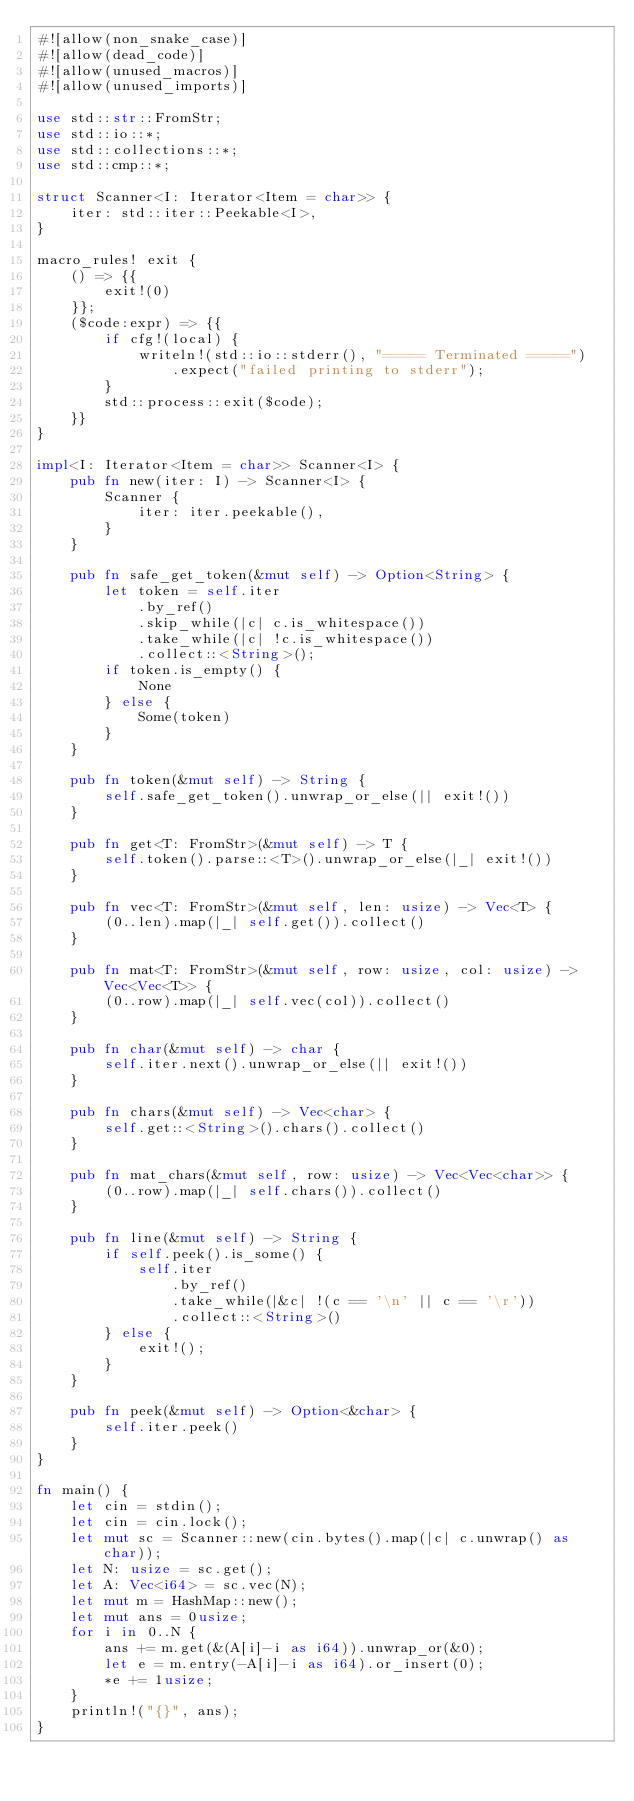<code> <loc_0><loc_0><loc_500><loc_500><_Rust_>#![allow(non_snake_case)]
#![allow(dead_code)]
#![allow(unused_macros)]
#![allow(unused_imports)]

use std::str::FromStr;
use std::io::*;
use std::collections::*;
use std::cmp::*;

struct Scanner<I: Iterator<Item = char>> {
    iter: std::iter::Peekable<I>,
}

macro_rules! exit {
    () => {{
        exit!(0)
    }};
    ($code:expr) => {{
        if cfg!(local) {
            writeln!(std::io::stderr(), "===== Terminated =====")
                .expect("failed printing to stderr");
        }
        std::process::exit($code);
    }}
}

impl<I: Iterator<Item = char>> Scanner<I> {
    pub fn new(iter: I) -> Scanner<I> {
        Scanner {
            iter: iter.peekable(),
        }
    }

    pub fn safe_get_token(&mut self) -> Option<String> {
        let token = self.iter
            .by_ref()
            .skip_while(|c| c.is_whitespace())
            .take_while(|c| !c.is_whitespace())
            .collect::<String>();
        if token.is_empty() {
            None
        } else {
            Some(token)
        }
    }

    pub fn token(&mut self) -> String {
        self.safe_get_token().unwrap_or_else(|| exit!())
    }

    pub fn get<T: FromStr>(&mut self) -> T {
        self.token().parse::<T>().unwrap_or_else(|_| exit!())
    }

    pub fn vec<T: FromStr>(&mut self, len: usize) -> Vec<T> {
        (0..len).map(|_| self.get()).collect()
    }

    pub fn mat<T: FromStr>(&mut self, row: usize, col: usize) -> Vec<Vec<T>> {
        (0..row).map(|_| self.vec(col)).collect()
    }

    pub fn char(&mut self) -> char {
        self.iter.next().unwrap_or_else(|| exit!())
    }

    pub fn chars(&mut self) -> Vec<char> {
        self.get::<String>().chars().collect()
    }

    pub fn mat_chars(&mut self, row: usize) -> Vec<Vec<char>> {
        (0..row).map(|_| self.chars()).collect()
    }

    pub fn line(&mut self) -> String {
        if self.peek().is_some() {
            self.iter
                .by_ref()
                .take_while(|&c| !(c == '\n' || c == '\r'))
                .collect::<String>()
        } else {
            exit!();
        }
    }

    pub fn peek(&mut self) -> Option<&char> {
        self.iter.peek()
    }
}

fn main() {
    let cin = stdin();
    let cin = cin.lock();
    let mut sc = Scanner::new(cin.bytes().map(|c| c.unwrap() as char));
    let N: usize = sc.get();
    let A: Vec<i64> = sc.vec(N);
    let mut m = HashMap::new();
    let mut ans = 0usize;
    for i in 0..N {
        ans += m.get(&(A[i]-i as i64)).unwrap_or(&0);
        let e = m.entry(-A[i]-i as i64).or_insert(0);
        *e += 1usize;
    }
    println!("{}", ans);
}
</code> 